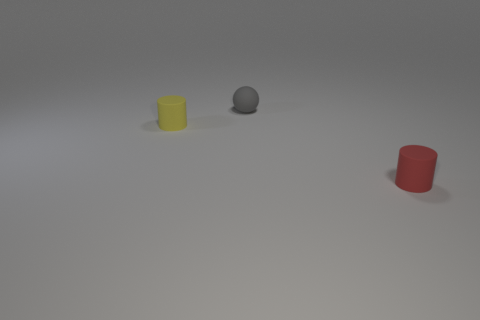Are there any other things that have the same color as the tiny matte ball?
Your response must be concise. No. How big is the gray sphere that is behind the small yellow thing?
Offer a very short reply. Small. Are there more small spheres than tiny brown rubber blocks?
Your answer should be very brief. Yes. What is the material of the gray ball?
Your answer should be very brief. Rubber. How many big purple things are there?
Your answer should be very brief. 0. There is a red object that is the same shape as the yellow matte object; what material is it?
Your answer should be very brief. Rubber. Is the material of the cylinder that is to the right of the small gray matte object the same as the yellow cylinder?
Provide a succinct answer. Yes. Is the number of small matte cylinders that are in front of the rubber ball greater than the number of tiny cylinders that are behind the tiny red cylinder?
Give a very brief answer. Yes. What is the size of the red thing?
Your answer should be very brief. Small. What shape is the small yellow object that is made of the same material as the gray thing?
Offer a terse response. Cylinder. 